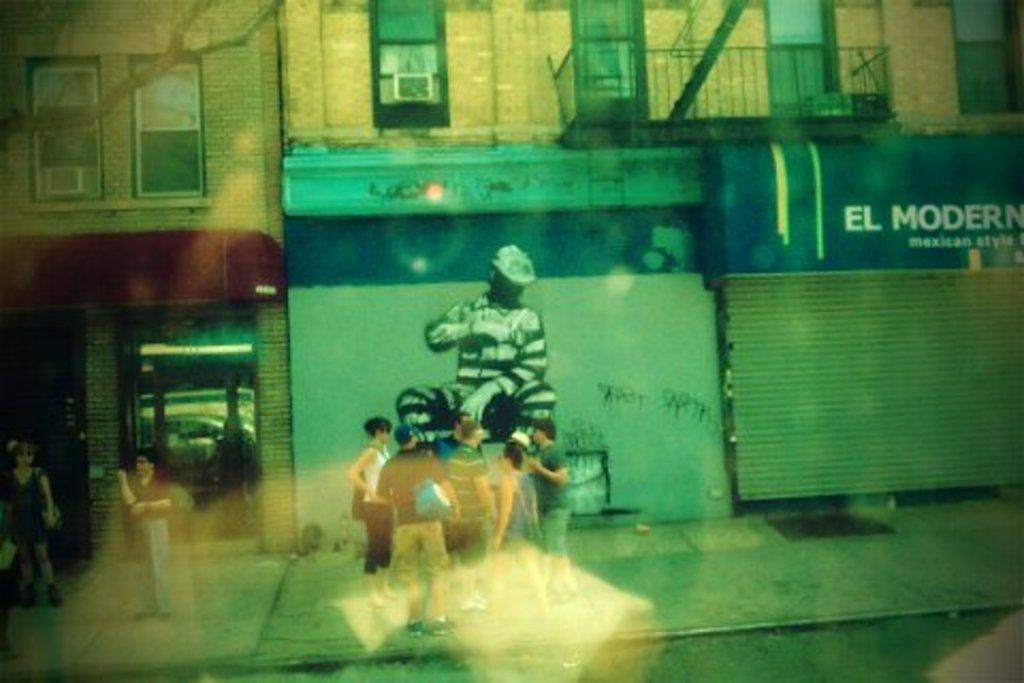Can you describe this image briefly? In this image we can see some group of persons standing on the footpath and at the background of the image there is building to which there is a painting and some shops and the painting is of a human being. 